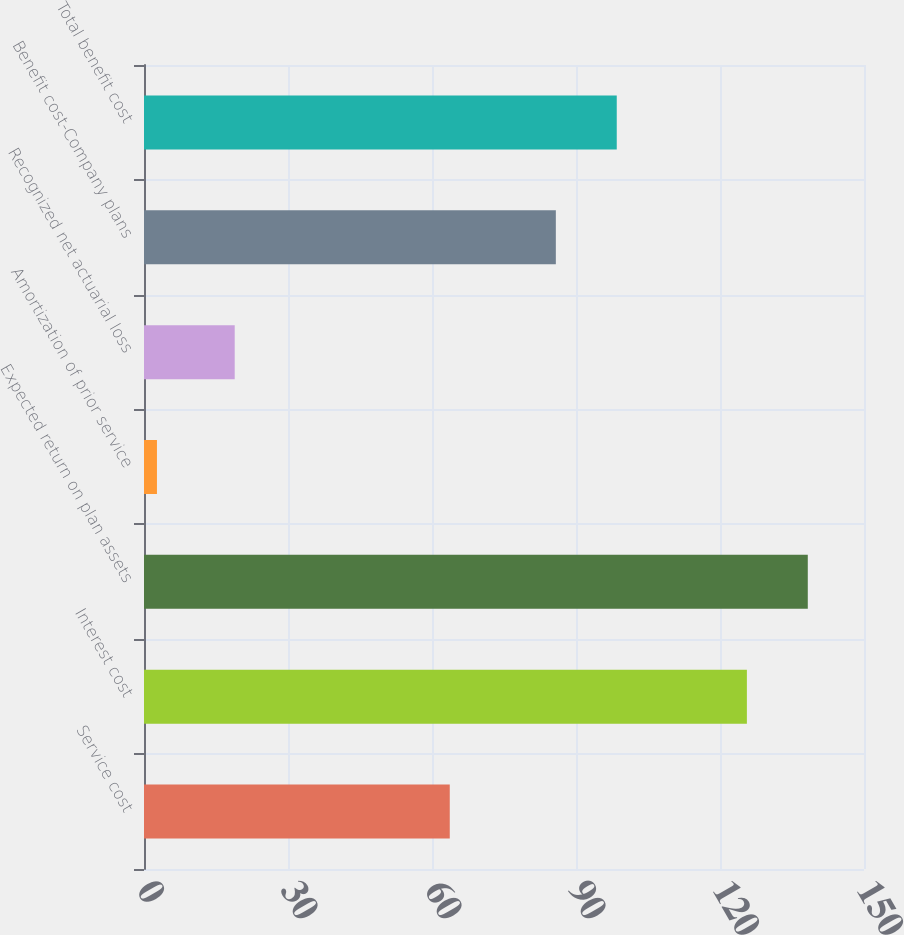<chart> <loc_0><loc_0><loc_500><loc_500><bar_chart><fcel>Service cost<fcel>Interest cost<fcel>Expected return on plan assets<fcel>Amortization of prior service<fcel>Recognized net actuarial loss<fcel>Benefit cost-Company plans<fcel>Total benefit cost<nl><fcel>63.7<fcel>125.6<fcel>138.29<fcel>2.7<fcel>18.9<fcel>85.8<fcel>98.49<nl></chart> 